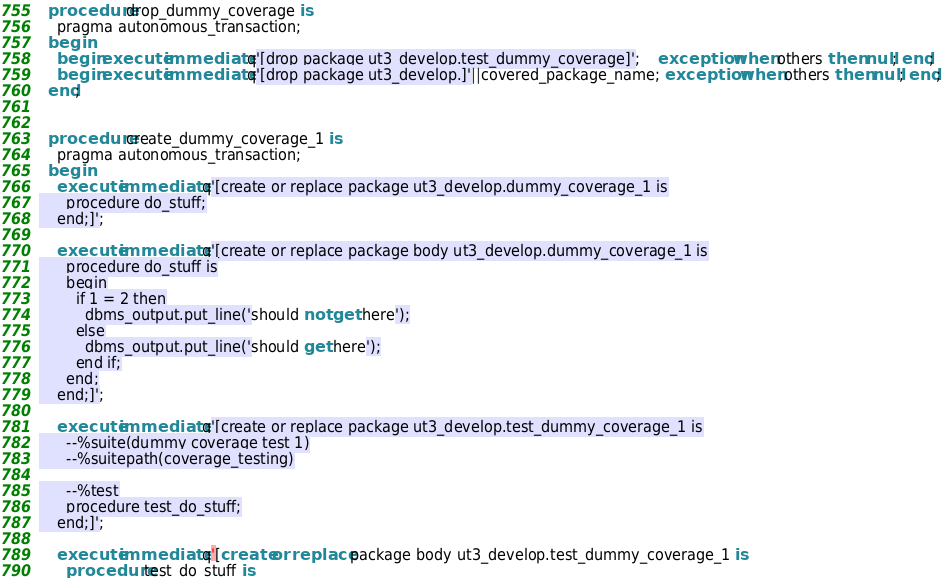Convert code to text. <code><loc_0><loc_0><loc_500><loc_500><_SQL_>  procedure drop_dummy_coverage is
    pragma autonomous_transaction;
  begin
    begin execute immediate q'[drop package ut3_develop.test_dummy_coverage]';    exception when others then null; end;
    begin execute immediate q'[drop package ut3_develop.]'||covered_package_name; exception when others then null; end;
  end;
 

  procedure create_dummy_coverage_1 is
    pragma autonomous_transaction;
  begin
    execute immediate q'[create or replace package ut3_develop.dummy_coverage_1 is
      procedure do_stuff;
    end;]';

    execute immediate q'[create or replace package body ut3_develop.dummy_coverage_1 is
      procedure do_stuff is
      begin
        if 1 = 2 then
          dbms_output.put_line('should not get here');
        else
          dbms_output.put_line('should get here');
        end if;
      end;
    end;]';

    execute immediate q'[create or replace package ut3_develop.test_dummy_coverage_1 is
      --%suite(dummy coverage test 1)
      --%suitepath(coverage_testing)

      --%test
      procedure test_do_stuff;
    end;]';

    execute immediate q'[create or replace package body ut3_develop.test_dummy_coverage_1 is
      procedure test_do_stuff is</code> 